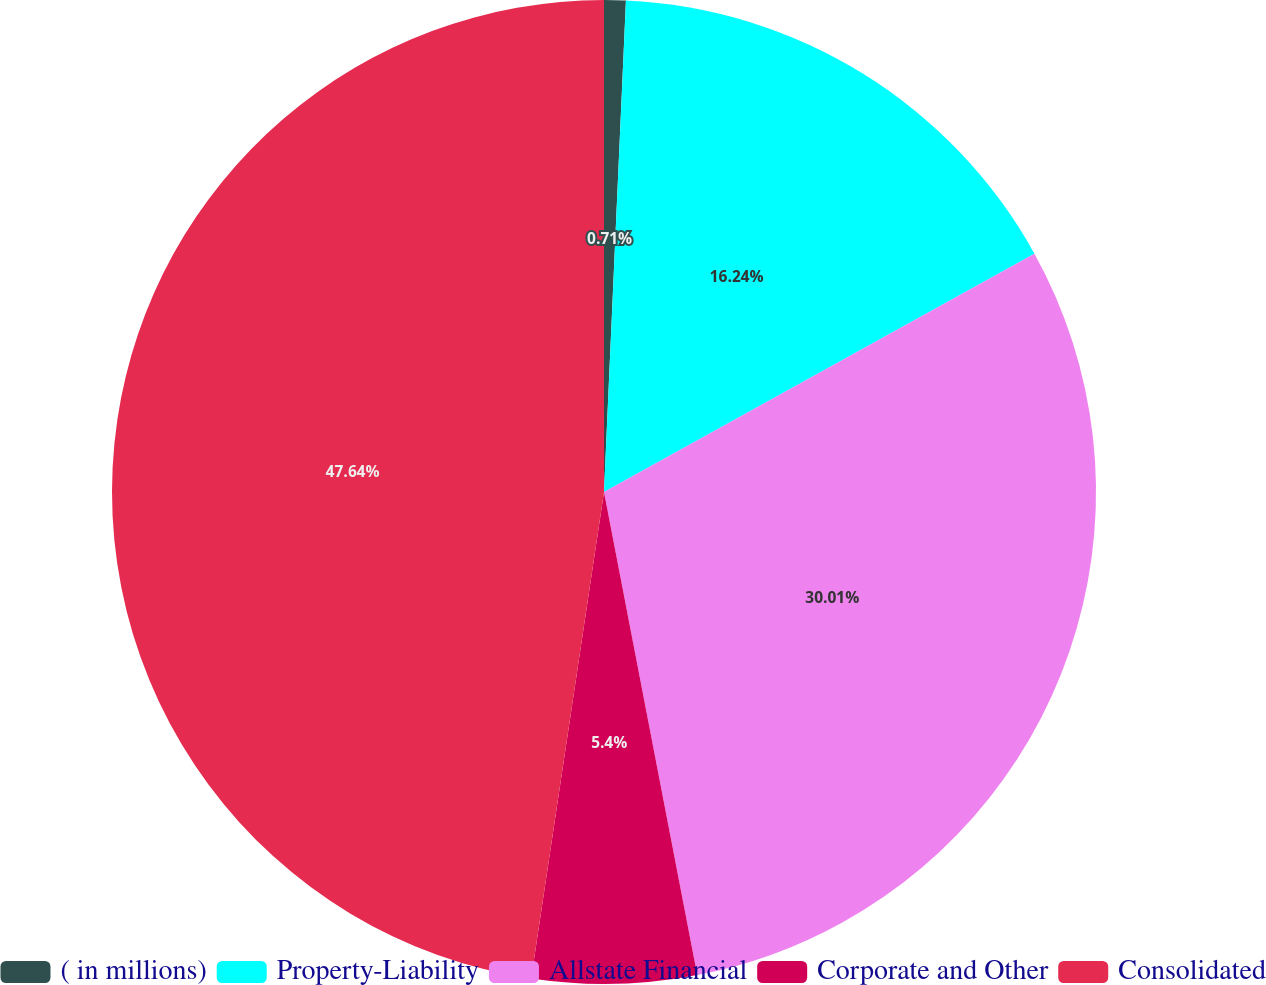<chart> <loc_0><loc_0><loc_500><loc_500><pie_chart><fcel>( in millions)<fcel>Property-Liability<fcel>Allstate Financial<fcel>Corporate and Other<fcel>Consolidated<nl><fcel>0.71%<fcel>16.24%<fcel>30.01%<fcel>5.4%<fcel>47.63%<nl></chart> 